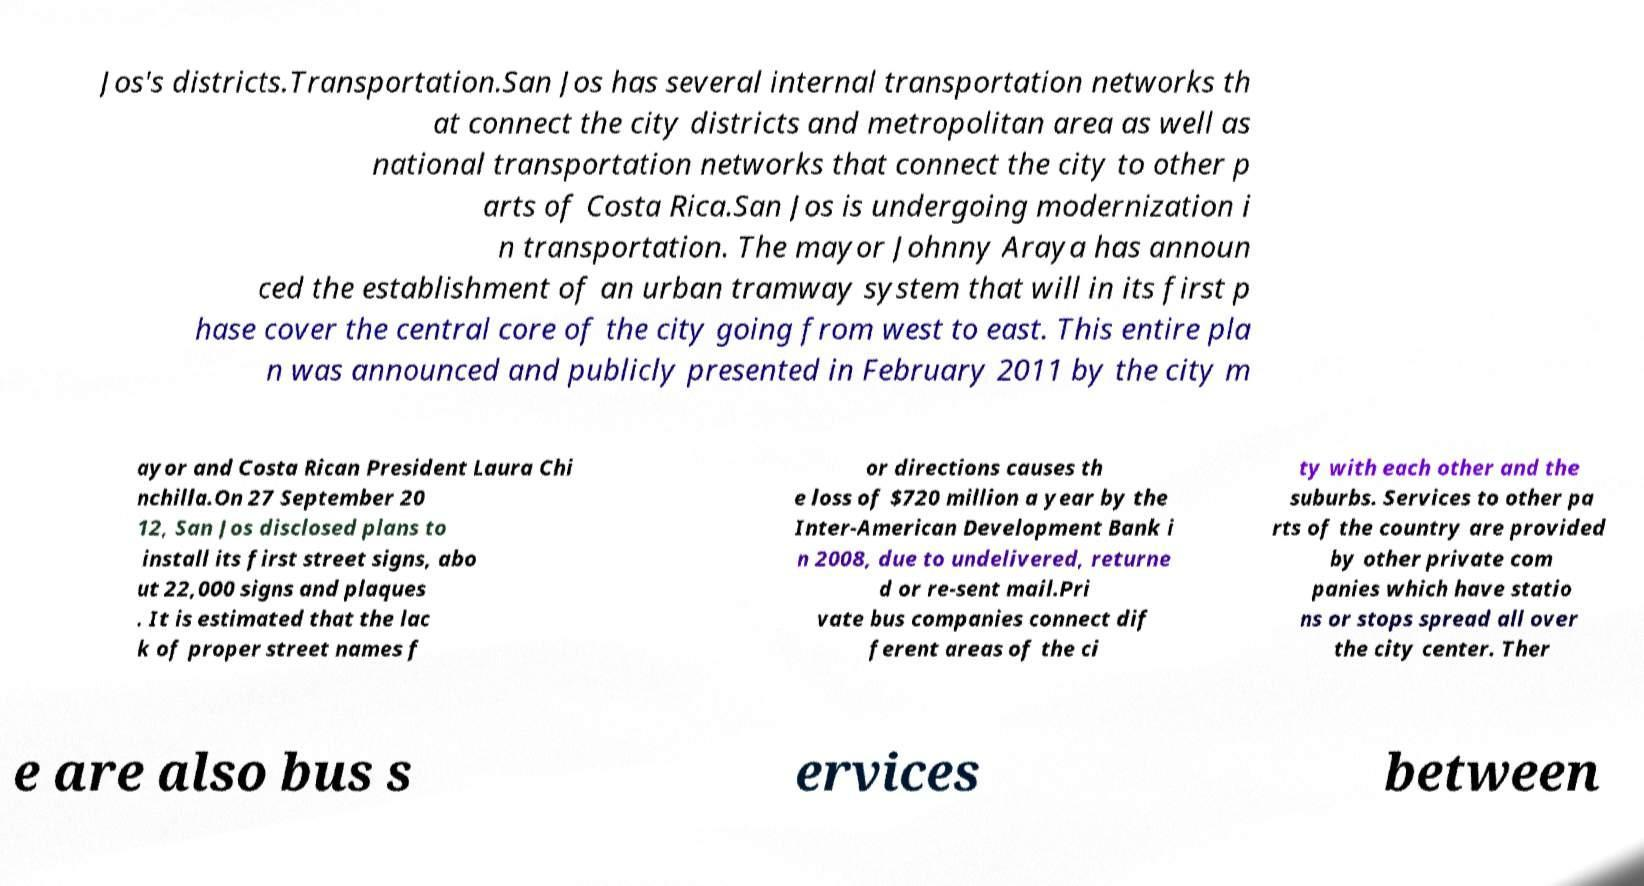What messages or text are displayed in this image? I need them in a readable, typed format. Jos's districts.Transportation.San Jos has several internal transportation networks th at connect the city districts and metropolitan area as well as national transportation networks that connect the city to other p arts of Costa Rica.San Jos is undergoing modernization i n transportation. The mayor Johnny Araya has announ ced the establishment of an urban tramway system that will in its first p hase cover the central core of the city going from west to east. This entire pla n was announced and publicly presented in February 2011 by the city m ayor and Costa Rican President Laura Chi nchilla.On 27 September 20 12, San Jos disclosed plans to install its first street signs, abo ut 22,000 signs and plaques . It is estimated that the lac k of proper street names f or directions causes th e loss of $720 million a year by the Inter-American Development Bank i n 2008, due to undelivered, returne d or re-sent mail.Pri vate bus companies connect dif ferent areas of the ci ty with each other and the suburbs. Services to other pa rts of the country are provided by other private com panies which have statio ns or stops spread all over the city center. Ther e are also bus s ervices between 